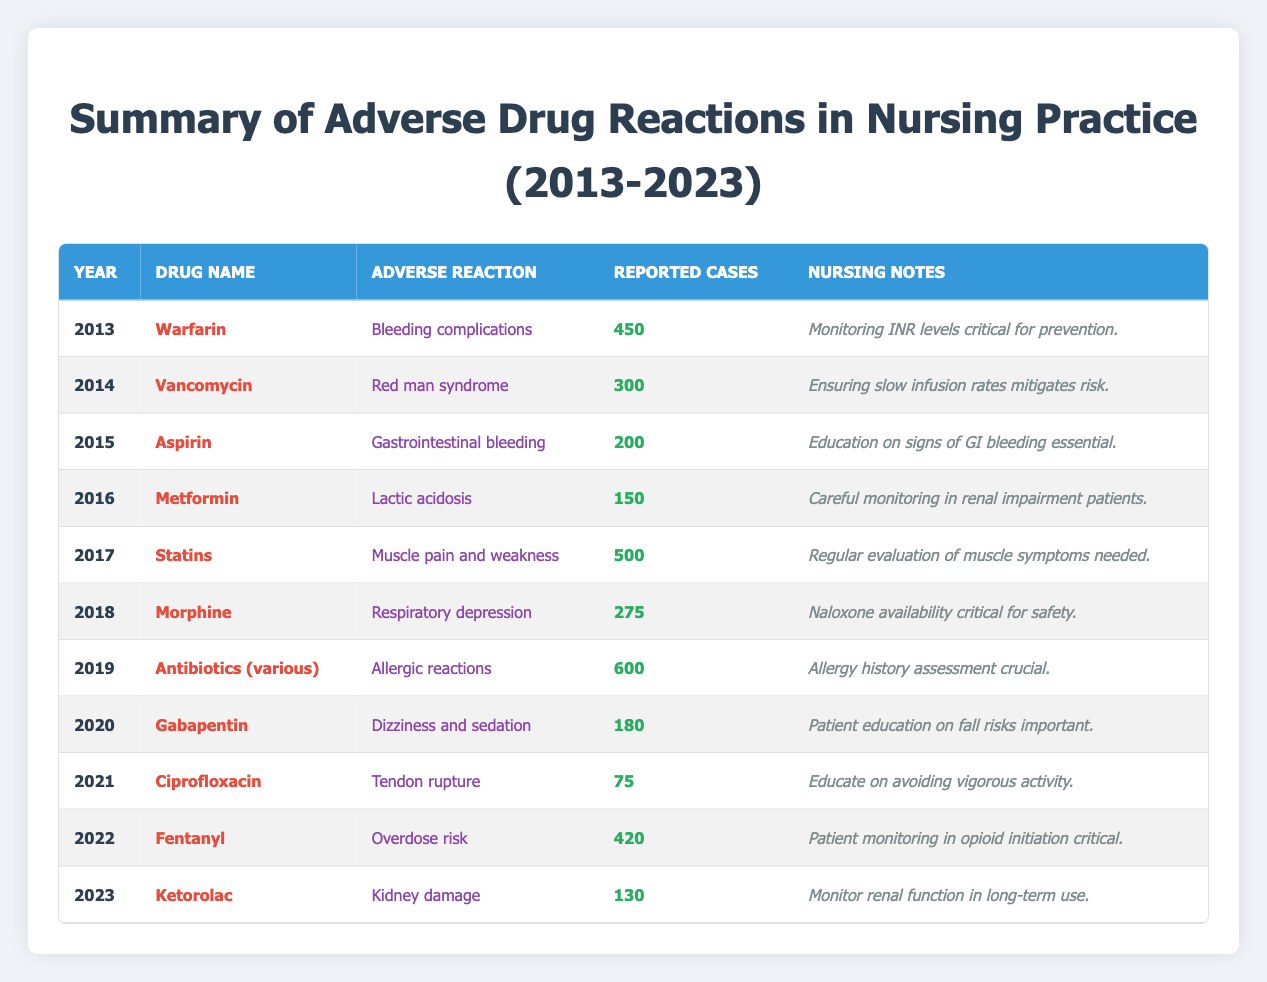What year had the highest reported cases of adverse drug reactions? By reviewing the table, I can see that the highest reported cases are for the year 2019 with 600 cases associated with antibiotics (various).
Answer: 2019 What was the nursing note associated with the adverse reaction of respiratory depression? Looking at the 2018 row in the table, the nursing note for morphine, which caused respiratory depression, is that naloxone availability is critical for safety.
Answer: Naloxone availability critical for safety How many adverse drug reactions were reported in 2017 and 2022 combined? First, I check the reported cases for both years: 2017 had 500 cases for statins and 2022 had 420 cases for fentanyl. I then add these two values: 500 + 420 = 920.
Answer: 920 Did the reported cases of adverse drug reactions increase or decrease from 2017 to 2023? In 2017, there were 500 reported cases, and in 2023, there were 130 cases. Since 130 is less than 500, this indicates a decrease.
Answer: Decrease What adverse reaction was reported most frequently for the drug Warfarin? The table indicates that the adverse reaction associated with Warfarin is bleeding complications, which was reported 450 times in 2013.
Answer: Bleeding complications Was there an increase in reported cases from 2013 to 2015? In 2013, there were 450 cases for Warfarin, and in 2015, there were 200 cases for Aspirin. Since 200 is less than 450, it indicates a decrease.
Answer: No What is the average number of reported cases of adverse reactions across all years from 2013 to 2023? I need to sum the reported cases: 450 + 300 + 200 + 150 + 500 + 275 + 600 + 180 + 75 + 420 + 130 = 2880. Then, I divide that sum by the number of years, which is 11: 2880 / 11 ≈ 261.82.
Answer: Approximately 261.82 Which drug had the least reported cases in a single year? In the table, I find that ciprofloxacin had the least reported cases, with only 75 cases in 2021.
Answer: Ciprofloxacin How many cases of allergic reactions were reported in total from the year 2014 to 2019? The reported cases for allergic reactions occurred only in 2019, where antibiotics (various) had 600 cases. The other years from 2014 to 2018 had different reactions, so I only take the single report: 600.
Answer: 600 